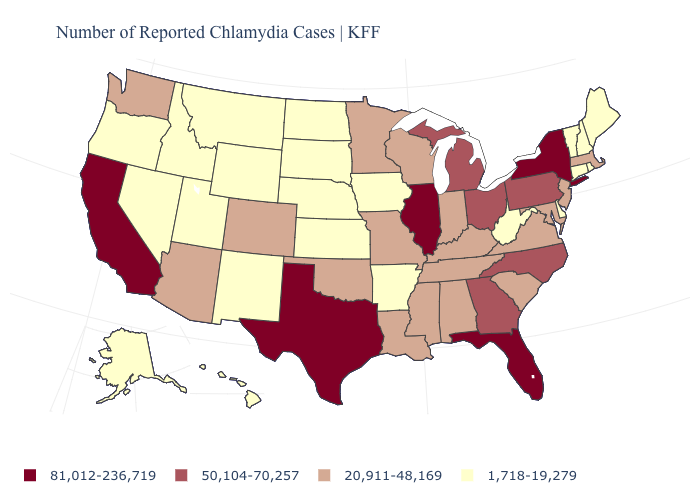Among the states that border Minnesota , does South Dakota have the lowest value?
Give a very brief answer. Yes. Name the states that have a value in the range 1,718-19,279?
Give a very brief answer. Alaska, Arkansas, Connecticut, Delaware, Hawaii, Idaho, Iowa, Kansas, Maine, Montana, Nebraska, Nevada, New Hampshire, New Mexico, North Dakota, Oregon, Rhode Island, South Dakota, Utah, Vermont, West Virginia, Wyoming. Does Delaware have the lowest value in the USA?
Answer briefly. Yes. What is the value of New Jersey?
Keep it brief. 20,911-48,169. Does Mississippi have the lowest value in the USA?
Be succinct. No. Name the states that have a value in the range 20,911-48,169?
Quick response, please. Alabama, Arizona, Colorado, Indiana, Kentucky, Louisiana, Maryland, Massachusetts, Minnesota, Mississippi, Missouri, New Jersey, Oklahoma, South Carolina, Tennessee, Virginia, Washington, Wisconsin. What is the highest value in states that border Illinois?
Answer briefly. 20,911-48,169. Name the states that have a value in the range 50,104-70,257?
Write a very short answer. Georgia, Michigan, North Carolina, Ohio, Pennsylvania. Does the map have missing data?
Answer briefly. No. Among the states that border Tennessee , does Alabama have the lowest value?
Answer briefly. No. Name the states that have a value in the range 20,911-48,169?
Concise answer only. Alabama, Arizona, Colorado, Indiana, Kentucky, Louisiana, Maryland, Massachusetts, Minnesota, Mississippi, Missouri, New Jersey, Oklahoma, South Carolina, Tennessee, Virginia, Washington, Wisconsin. Among the states that border Louisiana , does Texas have the lowest value?
Give a very brief answer. No. What is the lowest value in the USA?
Keep it brief. 1,718-19,279. Does the map have missing data?
Give a very brief answer. No. What is the value of Louisiana?
Short answer required. 20,911-48,169. 